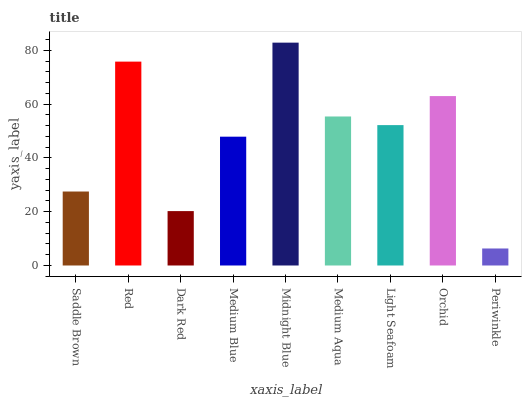Is Periwinkle the minimum?
Answer yes or no. Yes. Is Midnight Blue the maximum?
Answer yes or no. Yes. Is Red the minimum?
Answer yes or no. No. Is Red the maximum?
Answer yes or no. No. Is Red greater than Saddle Brown?
Answer yes or no. Yes. Is Saddle Brown less than Red?
Answer yes or no. Yes. Is Saddle Brown greater than Red?
Answer yes or no. No. Is Red less than Saddle Brown?
Answer yes or no. No. Is Light Seafoam the high median?
Answer yes or no. Yes. Is Light Seafoam the low median?
Answer yes or no. Yes. Is Orchid the high median?
Answer yes or no. No. Is Saddle Brown the low median?
Answer yes or no. No. 